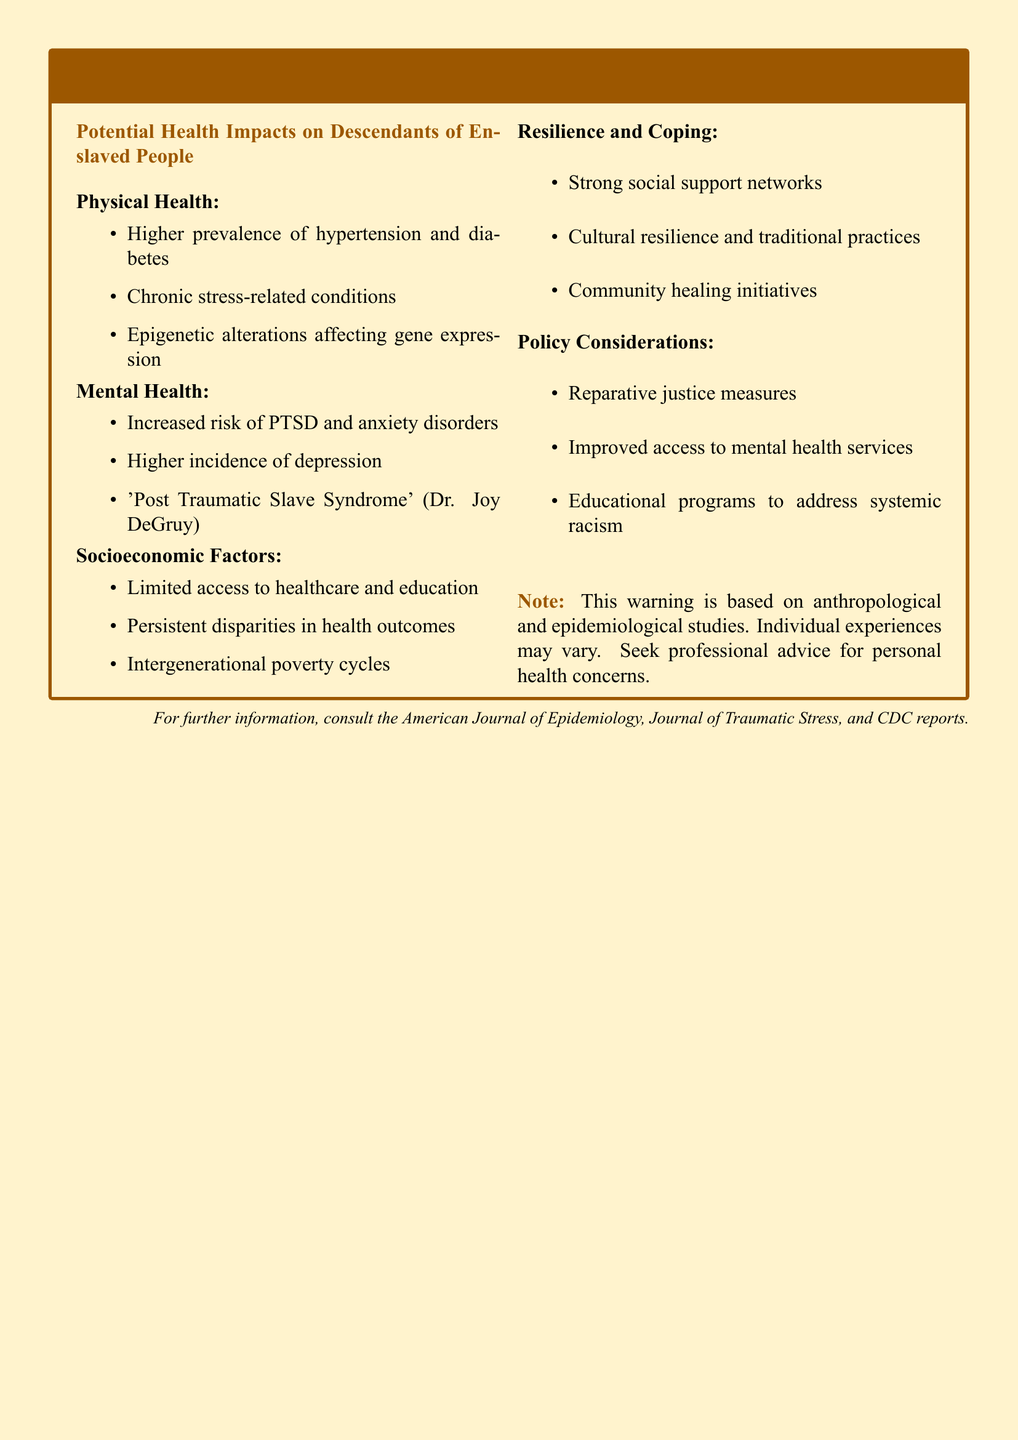what is the title of the warning label? The title is stated at the beginning of the document in bold font.
Answer: WARNING: Historical Trauma Impact what are the physical health impacts listed? The physical health impacts include items in a bullet list which can be retrieved directly from that section.
Answer: Higher prevalence of hypertension and diabetes, chronic stress-related conditions, epigenetic alterations affecting gene expression what mental health condition is mentioned as part of the impacts? The mental health conditions can be inferred from the bullet points in the mental health section.
Answer: PTSD and anxiety disorders who coined the term 'Post Traumatic Slave Syndrome'? The name associated with the term is provided in the relevant section of the document.
Answer: Dr. Joy DeGruy what socioeconomic factor is highlighted in the document? Socioeconomic factors are listed, and any one of them can serve as an answer.
Answer: Limited access to healthcare and education what resilience factor is emphasized in the document? The document specifies resilience and coping strategies in a bullet list; any specific factor can be mentioned.
Answer: Strong social support networks how many sections are there in the document? The sections are explicitly laid out, and counting them will lead to the answer.
Answer: Four what is the note at the end of the document regarding health concerns? The note near the end contains a cautionary statement relevant to the content.
Answer: Seek professional advice for personal health concerns 